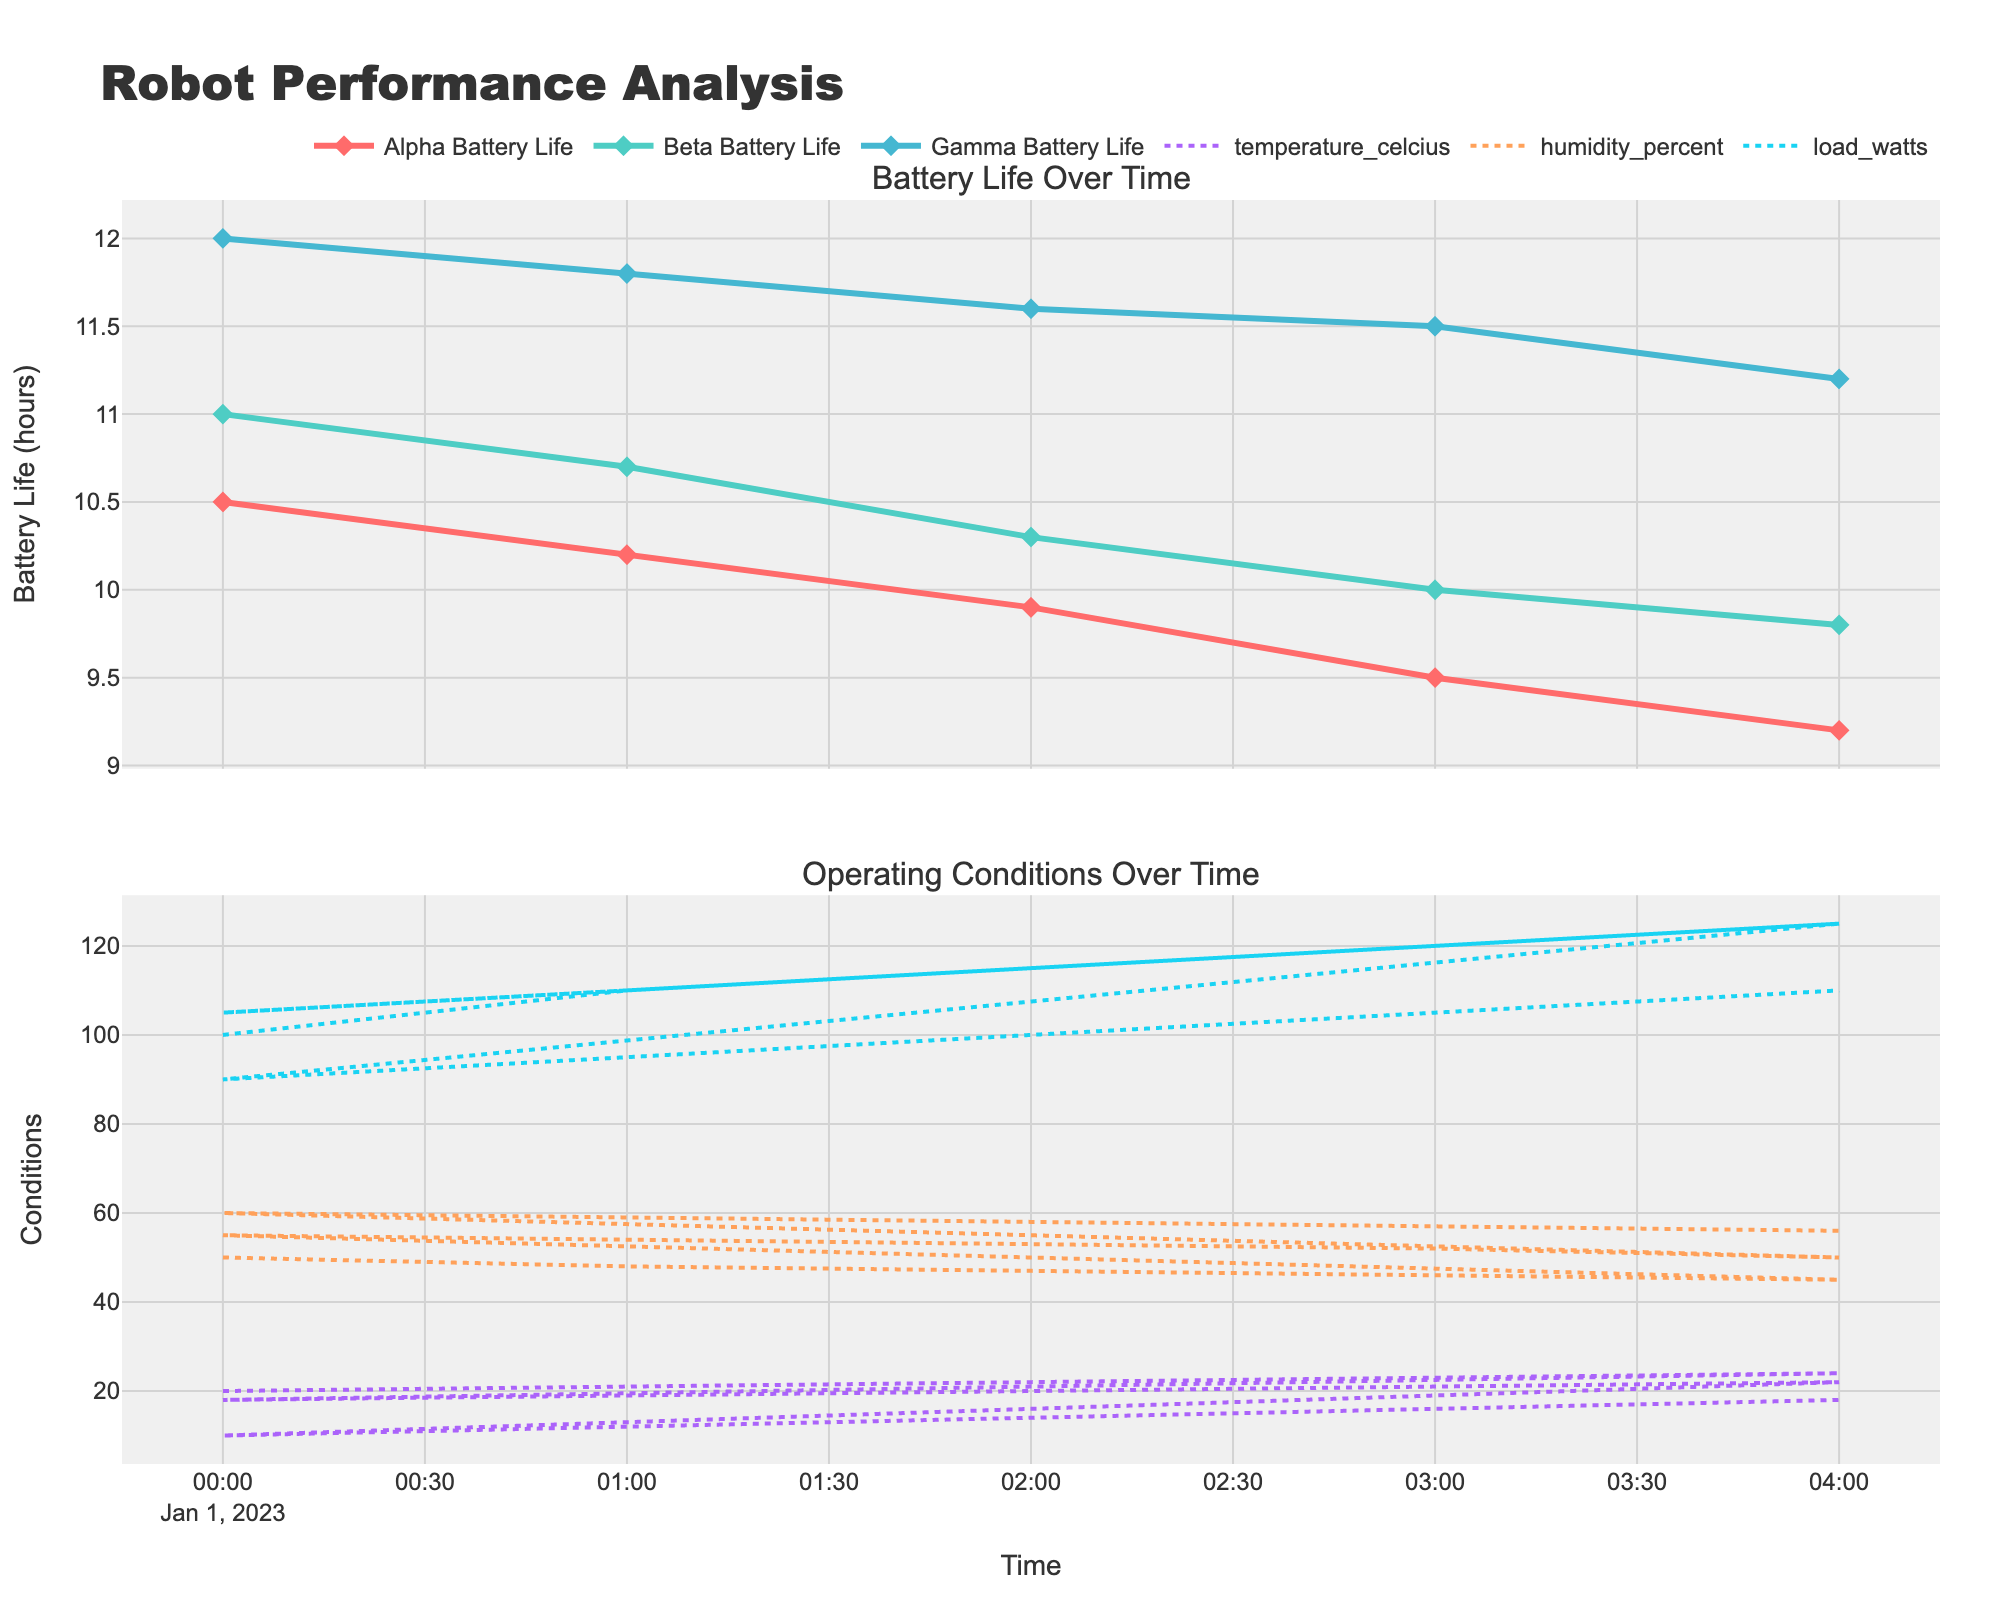What is the title of the figure? The title is typically displayed prominently at the top of the figure and provides a summary of what the figure represents, in this case, "Robot Performance Analysis".
Answer: Robot Performance Analysis How many robots are shown in the battery life plot? The battery life plot shows data for three distinct robots based on their unique identifiers: Alpha, Beta, and Gamma. Each robot's line is distinguishable by color and marker.
Answer: Three Which robot has the highest initial battery life? By examining the starting point on the y-axis for each robot's line in the battery life plot, Gamma starts at 12 hours, which is higher than Alpha and Beta.
Answer: Gamma What operating conditions are displayed in the second plot? The plot titled 'Operating Conditions Over Time' includes three continuous lines representing temperature (Celsius), humidity (percent), and load (watts) over time.
Answer: Temperature, Humidity, Load How does the battery life of Alpha change over the displayed time frame? By observing the line for Alpha in the battery life plot, the battery life starts at 10.5 hours and decreases progressively until it reaches 9.2 hours at the end of the time frame.
Answer: Declines from 10.5 to 9.2 hours During the observed time frame, which robot’s battery life decreases the most? Calculate the difference between the starting and ending battery life for each robot: Alpha (10.5 to 9.2), Beta (11.0 to 9.8), and Gamma (12.0 to 11.2). Alpha decreases by 1.3 hours, Beta by 1.2 hours, and Gamma by 0.8 hours. Hence, Alpha's battery life decreases the most.
Answer: Alpha At what time were the temperature, humidity, and load conditions most stable? Stability can be interpreted as having the least variation. By checking the plot of operating conditions, from 00:00 to 01:00, the lines appear less fluctuated for temperature, humidity, and load, indicating more stability.
Answer: 00:00 to 01:00 Which robot had the smallest change in battery life? The difference between the starting and ending battery life is smallest for Gamma, with a change from 12.0 to 11.2, which is 0.8 hours; smaller than Alpha (1.3 hours) and Beta (1.2 hours).
Answer: Gamma Does the load in watts increase or decrease over the observed time frame? The line representing load in the plot of operating conditions shows an upward trend from 100 watts to 125 watts, indicating an increase over time.
Answer: Increases What is the relationship between temperature and battery life for robot Beta? By comparing the trends in the temperature plot and the battery life plot for Beta, as the temperature increases from 18 to 22 degrees Celsius, Beta's battery life decreases from 11.0 to 9.8 hours. This suggests an inverse relationship where battery life decreases as temperature increases.
Answer: Inverse relationship 